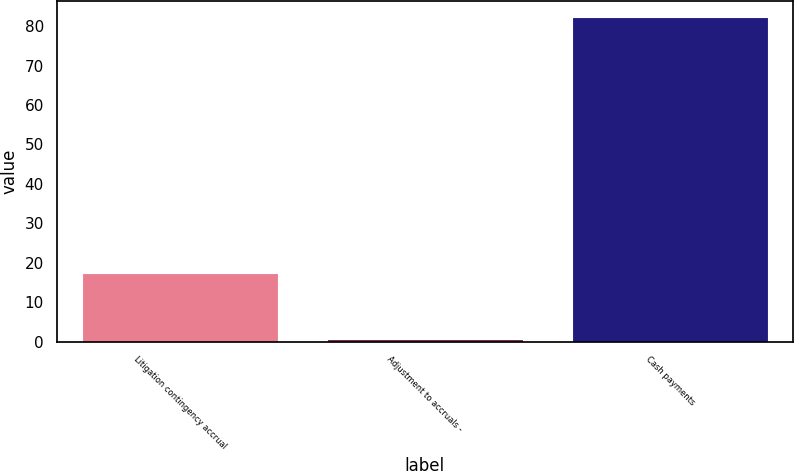Convert chart to OTSL. <chart><loc_0><loc_0><loc_500><loc_500><bar_chart><fcel>Litigation contingency accrual<fcel>Adjustment to accruals -<fcel>Cash payments<nl><fcel>17.34<fcel>0.7<fcel>82.2<nl></chart> 